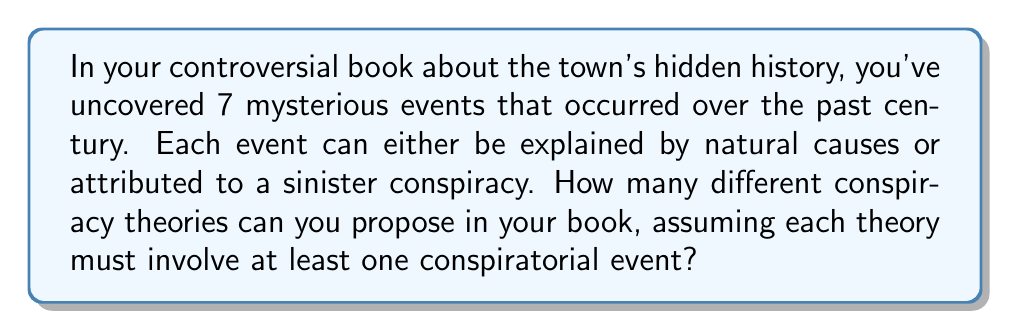Help me with this question. Let's approach this step-by-step:

1) We have 7 events, and each event can be either natural or conspiratorial.

2) This scenario can be modeled using sets, where each conspiracy theory is a subset of the 7 events.

3) The total number of possible subsets of a set with n elements is $2^n$.

4) However, we need to exclude the case where all events are considered natural (the empty set), as the question states that each theory must involve at least one conspiratorial event.

5) Therefore, the number of possible conspiracy theories is:

   $$ \text{Total theories} = 2^7 - 1 $$

6) Calculating:
   $$ 2^7 = 128 $$
   $$ 128 - 1 = 127 $$

Thus, there are 127 possible conspiracy theories that can be proposed in the book.

This result can also be understood combinatorially:
$$ \binom{7}{1} + \binom{7}{2} + \binom{7}{3} + \binom{7}{4} + \binom{7}{5} + \binom{7}{6} + \binom{7}{7} = 127 $$

Which represents the sum of choosing 1, 2, 3, ..., or all 7 events to be conspiratorial.
Answer: 127 possible conspiracy theories 